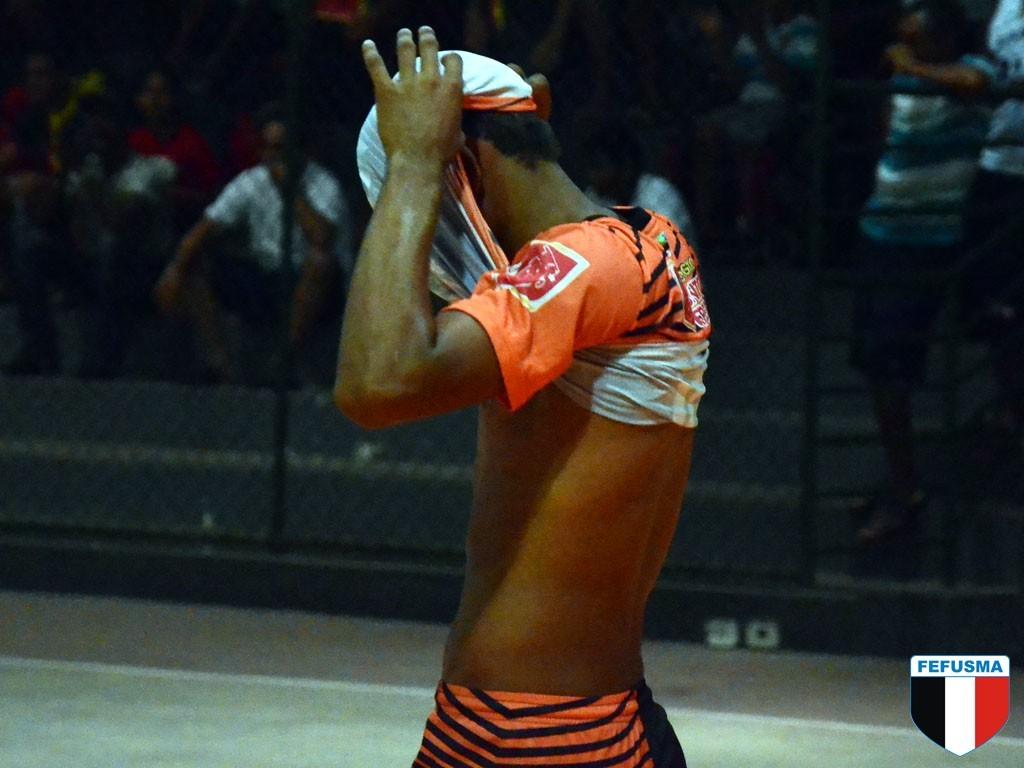What team does this man play for?
Your answer should be very brief. Fefusma. 